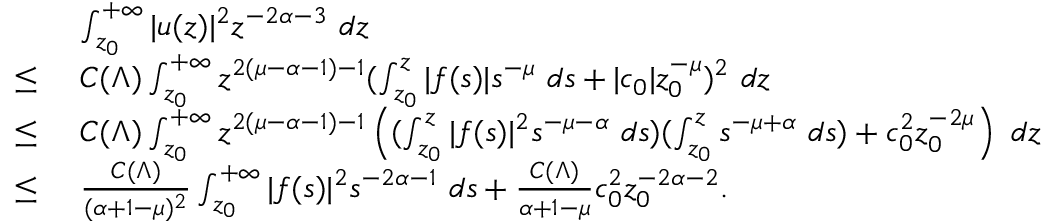Convert formula to latex. <formula><loc_0><loc_0><loc_500><loc_500>\begin{array} { r l } & { \ \int _ { z _ { 0 } } ^ { + \infty } | u ( z ) | ^ { 2 } z ^ { - 2 \alpha - 3 } \ d z } \\ { \leq } & { \ C ( \Lambda ) \int _ { z _ { 0 } } ^ { + \infty } z ^ { 2 ( \mu - \alpha - 1 ) - 1 } ( \int _ { z _ { 0 } } ^ { z } | f ( s ) | s ^ { - \mu } \ d s + | c _ { 0 } | z _ { 0 } ^ { - \mu } ) ^ { 2 } \ d z } \\ { \leq } & { \ C ( \Lambda ) \int _ { z _ { 0 } } ^ { + \infty } z ^ { 2 ( \mu - \alpha - 1 ) - 1 } \left ( ( \int _ { z _ { 0 } } ^ { z } | f ( s ) | ^ { 2 } s ^ { - \mu - \alpha } \ d s ) ( \int _ { z _ { 0 } } ^ { z } s ^ { - \mu + \alpha } \ d s ) + c _ { 0 } ^ { 2 } z _ { 0 } ^ { - 2 \mu } \right ) \ d z } \\ { \leq } & { \ \frac { C ( \Lambda ) } { ( \alpha + 1 - \mu ) ^ { 2 } } \int _ { z _ { 0 } } ^ { + \infty } | f ( s ) | ^ { 2 } s ^ { - 2 \alpha - 1 } \ d s + \frac { C ( \Lambda ) } { \alpha + 1 - \mu } c _ { 0 } ^ { 2 } z _ { 0 } ^ { - 2 \alpha - 2 } . } \end{array}</formula> 